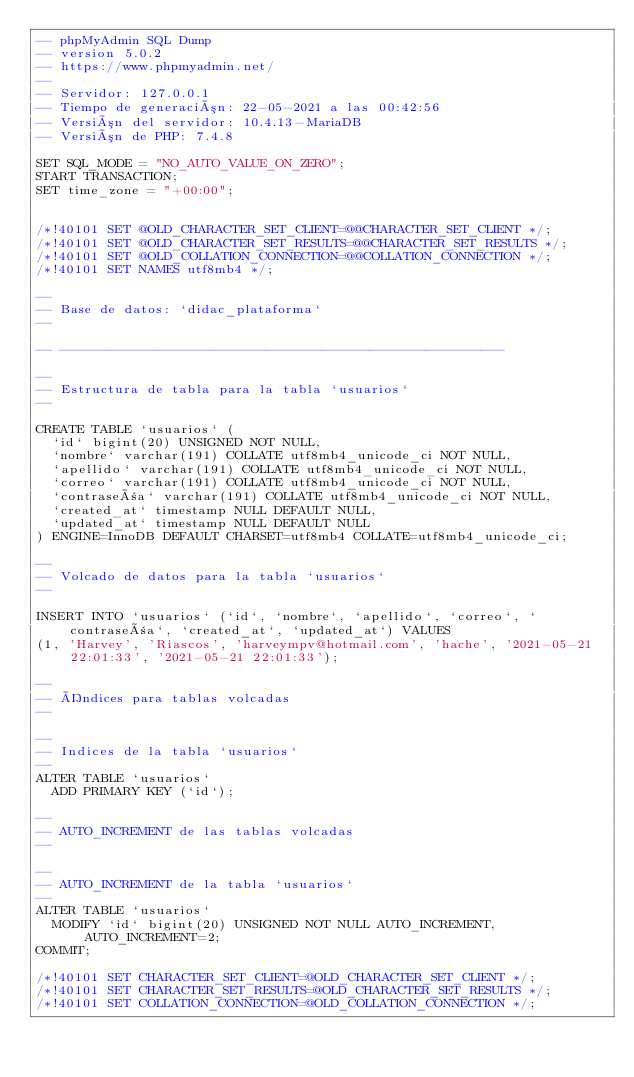<code> <loc_0><loc_0><loc_500><loc_500><_SQL_>-- phpMyAdmin SQL Dump
-- version 5.0.2
-- https://www.phpmyadmin.net/
--
-- Servidor: 127.0.0.1
-- Tiempo de generación: 22-05-2021 a las 00:42:56
-- Versión del servidor: 10.4.13-MariaDB
-- Versión de PHP: 7.4.8

SET SQL_MODE = "NO_AUTO_VALUE_ON_ZERO";
START TRANSACTION;
SET time_zone = "+00:00";


/*!40101 SET @OLD_CHARACTER_SET_CLIENT=@@CHARACTER_SET_CLIENT */;
/*!40101 SET @OLD_CHARACTER_SET_RESULTS=@@CHARACTER_SET_RESULTS */;
/*!40101 SET @OLD_COLLATION_CONNECTION=@@COLLATION_CONNECTION */;
/*!40101 SET NAMES utf8mb4 */;

--
-- Base de datos: `didac_plataforma`
--

-- --------------------------------------------------------

--
-- Estructura de tabla para la tabla `usuarios`
--

CREATE TABLE `usuarios` (
  `id` bigint(20) UNSIGNED NOT NULL,
  `nombre` varchar(191) COLLATE utf8mb4_unicode_ci NOT NULL,
  `apellido` varchar(191) COLLATE utf8mb4_unicode_ci NOT NULL,
  `correo` varchar(191) COLLATE utf8mb4_unicode_ci NOT NULL,
  `contraseña` varchar(191) COLLATE utf8mb4_unicode_ci NOT NULL,
  `created_at` timestamp NULL DEFAULT NULL,
  `updated_at` timestamp NULL DEFAULT NULL
) ENGINE=InnoDB DEFAULT CHARSET=utf8mb4 COLLATE=utf8mb4_unicode_ci;

--
-- Volcado de datos para la tabla `usuarios`
--

INSERT INTO `usuarios` (`id`, `nombre`, `apellido`, `correo`, `contraseña`, `created_at`, `updated_at`) VALUES
(1, 'Harvey', 'Riascos', 'harveympv@hotmail.com', 'hache', '2021-05-21 22:01:33', '2021-05-21 22:01:33');

--
-- Índices para tablas volcadas
--

--
-- Indices de la tabla `usuarios`
--
ALTER TABLE `usuarios`
  ADD PRIMARY KEY (`id`);

--
-- AUTO_INCREMENT de las tablas volcadas
--

--
-- AUTO_INCREMENT de la tabla `usuarios`
--
ALTER TABLE `usuarios`
  MODIFY `id` bigint(20) UNSIGNED NOT NULL AUTO_INCREMENT, AUTO_INCREMENT=2;
COMMIT;

/*!40101 SET CHARACTER_SET_CLIENT=@OLD_CHARACTER_SET_CLIENT */;
/*!40101 SET CHARACTER_SET_RESULTS=@OLD_CHARACTER_SET_RESULTS */;
/*!40101 SET COLLATION_CONNECTION=@OLD_COLLATION_CONNECTION */;
</code> 